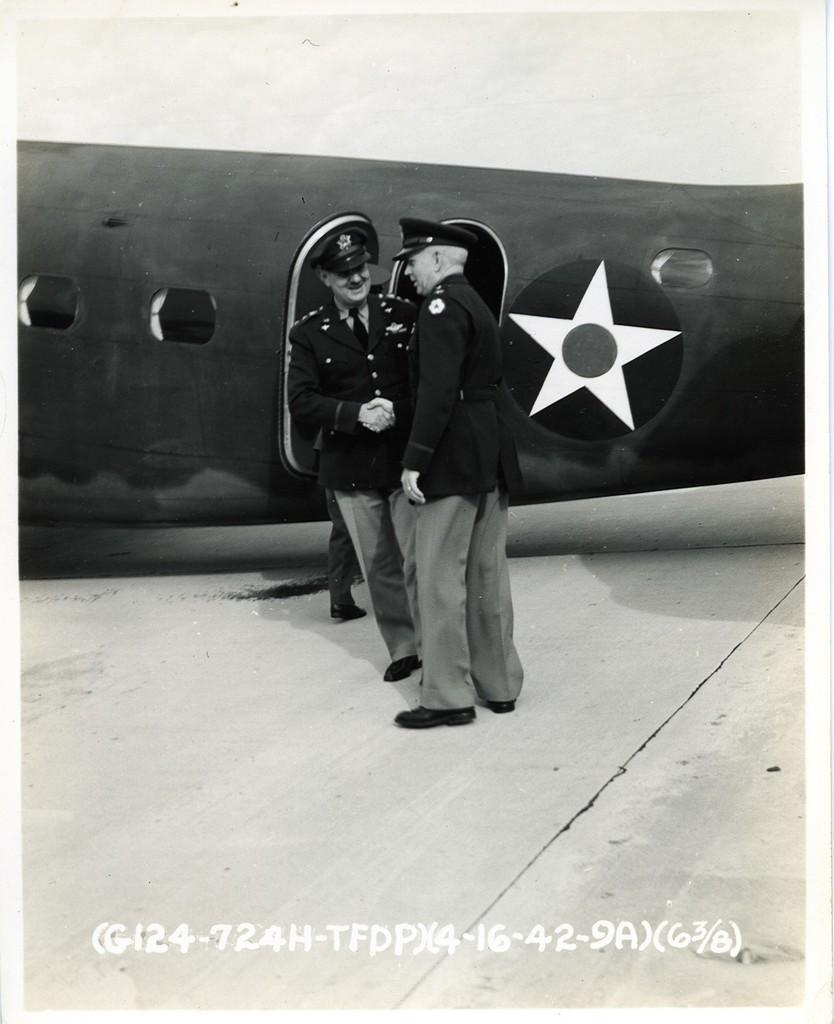In one or two sentences, can you explain what this image depicts? In this image, we can see an aircraft, there are two men standing. At the bottom we can see some text. 